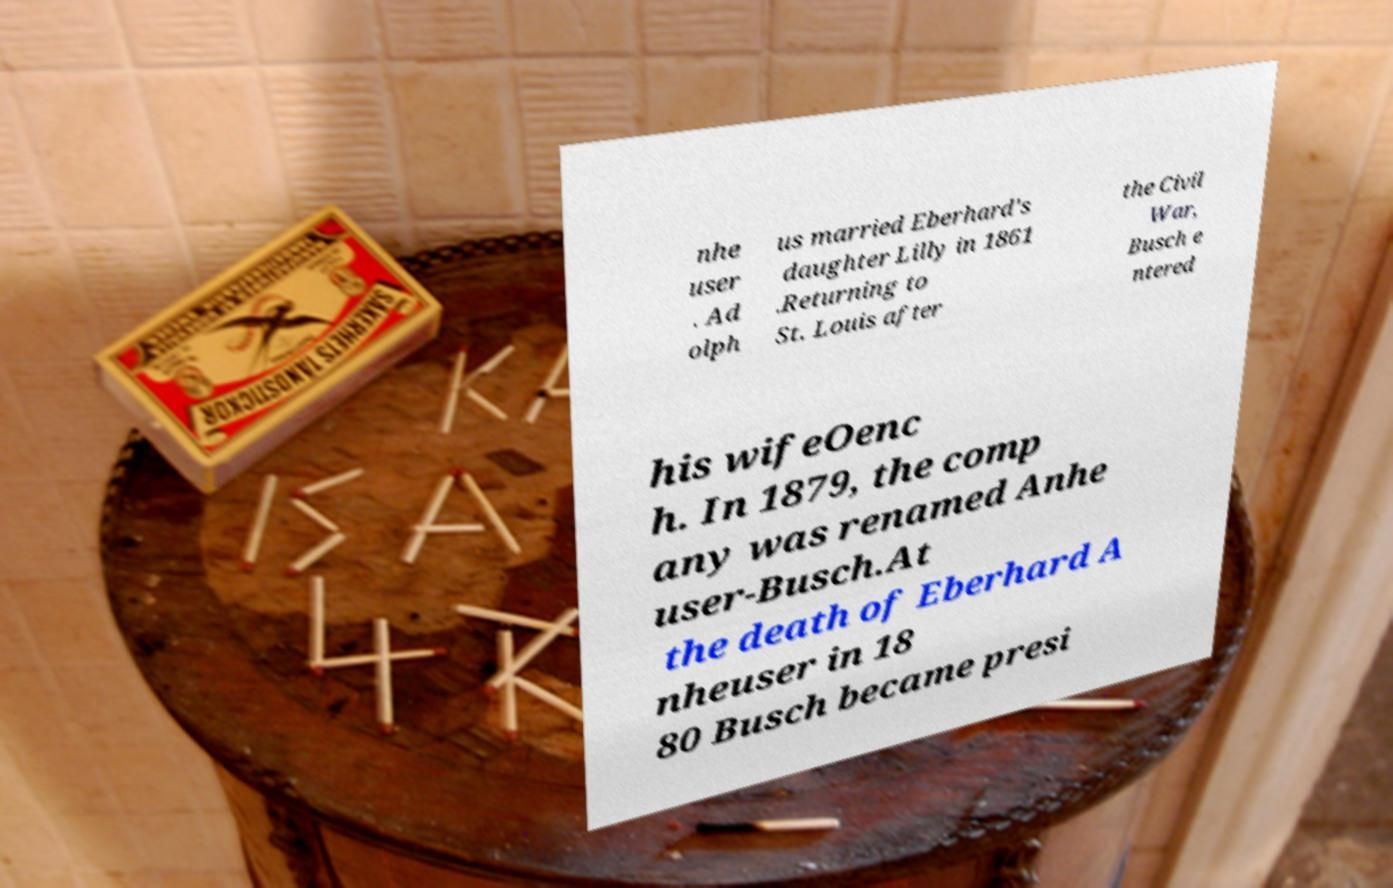Could you assist in decoding the text presented in this image and type it out clearly? nhe user . Ad olph us married Eberhard's daughter Lilly in 1861 .Returning to St. Louis after the Civil War, Busch e ntered his wifeOenc h. In 1879, the comp any was renamed Anhe user-Busch.At the death of Eberhard A nheuser in 18 80 Busch became presi 